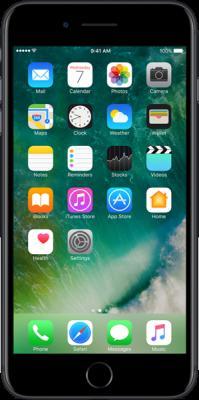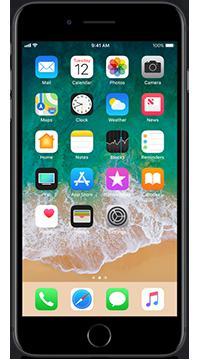The first image is the image on the left, the second image is the image on the right. Given the left and right images, does the statement "There are more phones in the image on the left." hold true? Answer yes or no. No. 